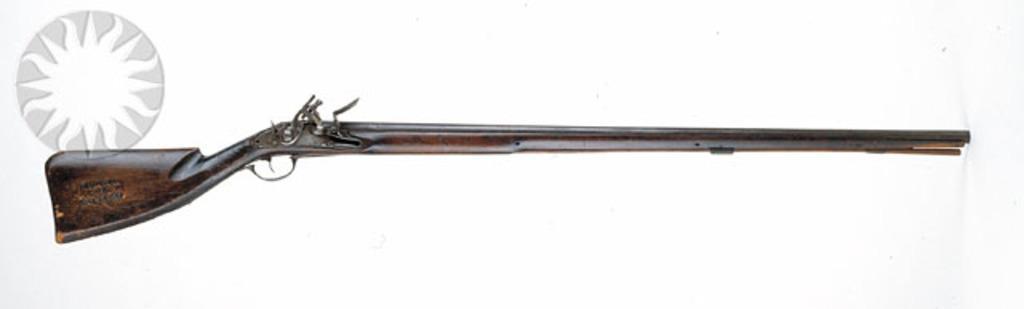Can you describe this image briefly? In this image we can see one gun on the surface and one sticker. 